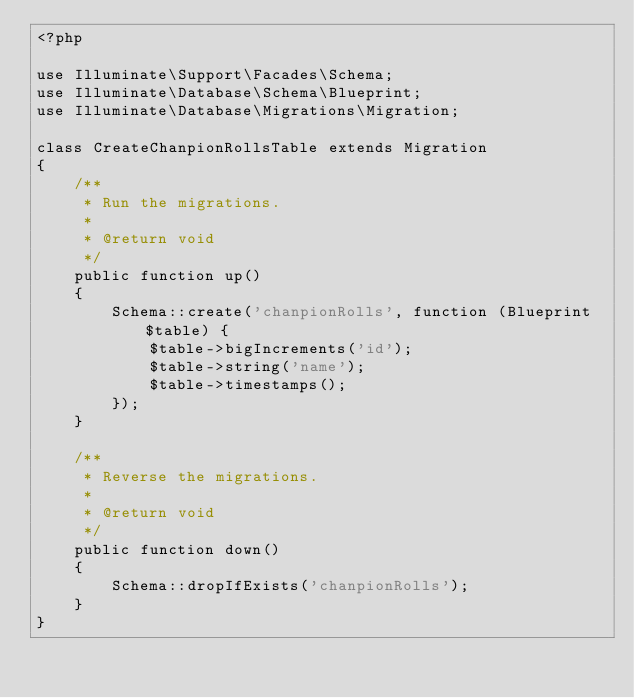<code> <loc_0><loc_0><loc_500><loc_500><_PHP_><?php

use Illuminate\Support\Facades\Schema;
use Illuminate\Database\Schema\Blueprint;
use Illuminate\Database\Migrations\Migration;

class CreateChanpionRollsTable extends Migration
{
    /**
     * Run the migrations.
     *
     * @return void
     */
    public function up()
    {
        Schema::create('chanpionRolls', function (Blueprint $table) {
            $table->bigIncrements('id');
            $table->string('name');
            $table->timestamps();
        });
    }

    /**
     * Reverse the migrations.
     *
     * @return void
     */
    public function down()
    {
        Schema::dropIfExists('chanpionRolls');
    }
}
</code> 